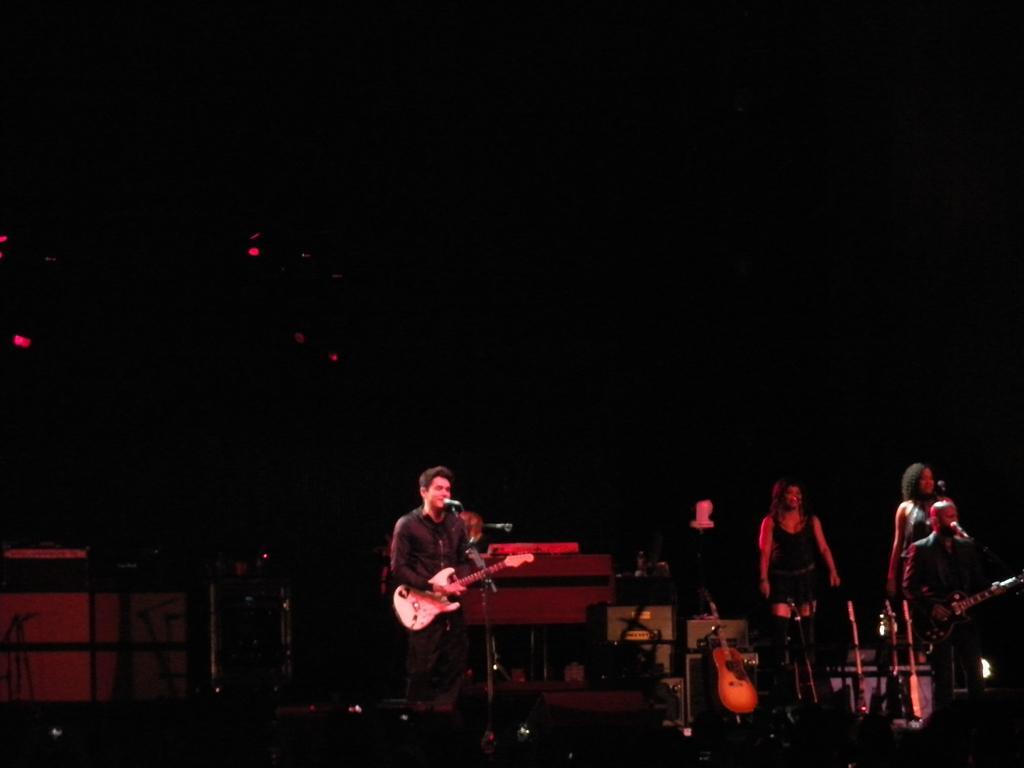How would you summarize this image in a sentence or two? In this picture we can see some group of people on the stage holding and playing some musical instruments. 